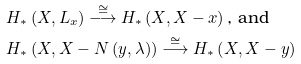<formula> <loc_0><loc_0><loc_500><loc_500>& H _ { \ast } \left ( X , L _ { x } \right ) \overset { \cong } { \longrightarrow } H _ { \ast } \left ( X , X - x \right ) \text {, and} \\ & H _ { \ast } \left ( X , X - N \left ( y , \lambda \right ) \right ) \overset { \cong } { \longrightarrow } H _ { \ast } \left ( X , X - y \right )</formula> 